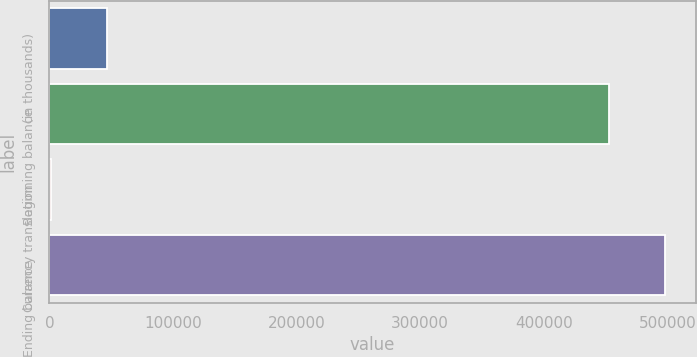Convert chart to OTSL. <chart><loc_0><loc_0><loc_500><loc_500><bar_chart><fcel>(in thousands)<fcel>Beginning balance<fcel>Currency translation<fcel>Ending balance<nl><fcel>46693.7<fcel>452824<fcel>1472<fcel>498046<nl></chart> 